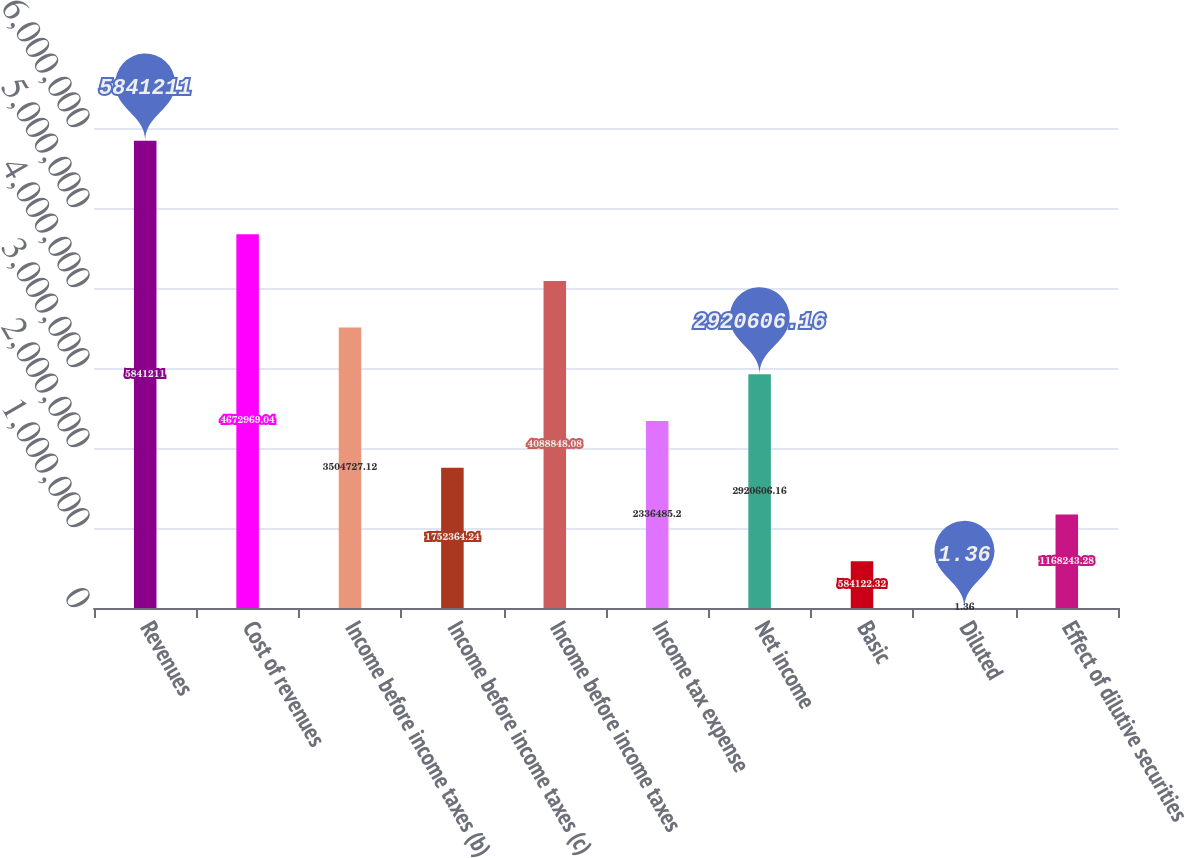Convert chart. <chart><loc_0><loc_0><loc_500><loc_500><bar_chart><fcel>Revenues<fcel>Cost of revenues<fcel>Income before income taxes (b)<fcel>Income before income taxes (c)<fcel>Income before income taxes<fcel>Income tax expense<fcel>Net income<fcel>Basic<fcel>Diluted<fcel>Effect of dilutive securities<nl><fcel>5.84121e+06<fcel>4.67297e+06<fcel>3.50473e+06<fcel>1.75236e+06<fcel>4.08885e+06<fcel>2.33649e+06<fcel>2.92061e+06<fcel>584122<fcel>1.36<fcel>1.16824e+06<nl></chart> 